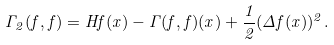<formula> <loc_0><loc_0><loc_500><loc_500>\Gamma _ { 2 } ( f , f ) = H f ( x ) - \Gamma ( f , f ) ( x ) + \frac { 1 } { 2 } ( \Delta f ( x ) ) ^ { 2 } .</formula> 